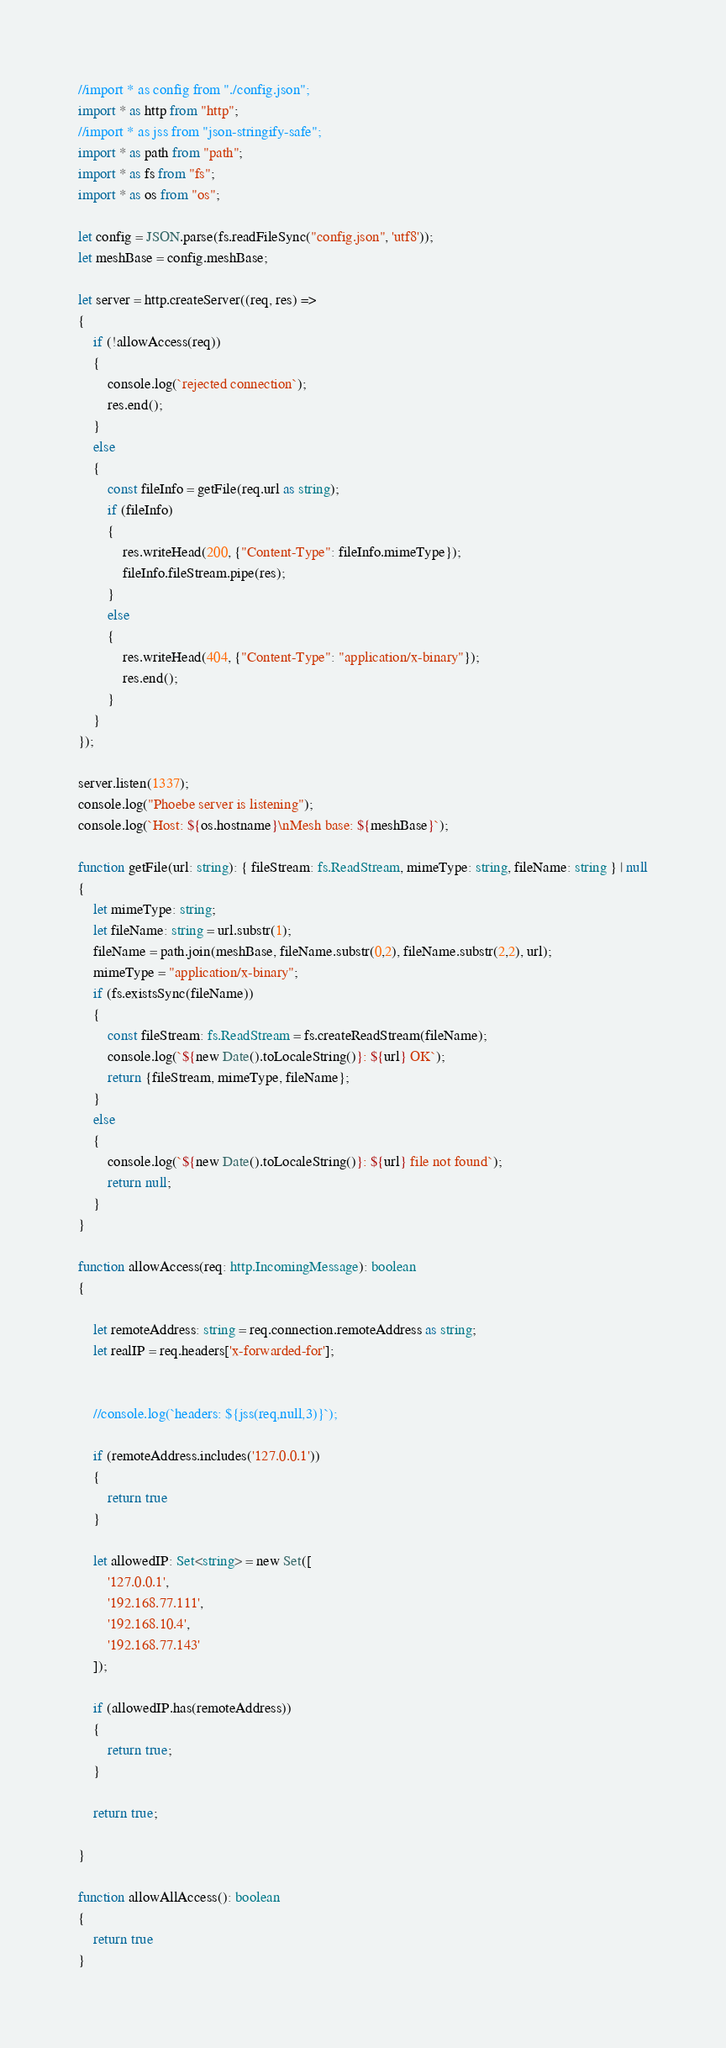<code> <loc_0><loc_0><loc_500><loc_500><_TypeScript_>//import * as config from "./config.json";
import * as http from "http";
//import * as jss from "json-stringify-safe";
import * as path from "path";
import * as fs from "fs";
import * as os from "os";

let config = JSON.parse(fs.readFileSync("config.json", 'utf8'));
let meshBase = config.meshBase;

let server = http.createServer((req, res) =>
{
    if (!allowAccess(req))
    {
        console.log(`rejected connection`);
        res.end();
    }    
    else
    {        
        const fileInfo = getFile(req.url as string);
        if (fileInfo)
        {
            res.writeHead(200, {"Content-Type": fileInfo.mimeType});            
            fileInfo.fileStream.pipe(res);
        }
        else
        {
            res.writeHead(404, {"Content-Type": "application/x-binary"});
            res.end();
        }
    }
});

server.listen(1337);
console.log("Phoebe server is listening");
console.log(`Host: ${os.hostname}\nMesh base: ${meshBase}`);

function getFile(url: string): { fileStream: fs.ReadStream, mimeType: string, fileName: string } | null
{
    let mimeType: string;
    let fileName: string = url.substr(1);
    fileName = path.join(meshBase, fileName.substr(0,2), fileName.substr(2,2), url);    
    mimeType = "application/x-binary";
    if (fs.existsSync(fileName))
    {
        const fileStream: fs.ReadStream = fs.createReadStream(fileName);
        console.log(`${new Date().toLocaleString()}: ${url} OK`);
        return {fileStream, mimeType, fileName};
    }
    else
    {
        console.log(`${new Date().toLocaleString()}: ${url} file not found`);
        return null;
    }
}

function allowAccess(req: http.IncomingMessage): boolean
{

    let remoteAddress: string = req.connection.remoteAddress as string;
    let realIP = req.headers['x-forwarded-for'];
    
    
    //console.log(`headers: ${jss(req,null,3)}`);

    if (remoteAddress.includes('127.0.0.1'))
    {
        return true
    }

    let allowedIP: Set<string> = new Set([
        '127.0.0.1',
        '192.168.77.111',
        '192.168.10.4',
        '192.168.77.143'
    ]);

    if (allowedIP.has(remoteAddress))
    {
        return true;
    }

    return true;

}

function allowAllAccess(): boolean
{
    return true
}</code> 